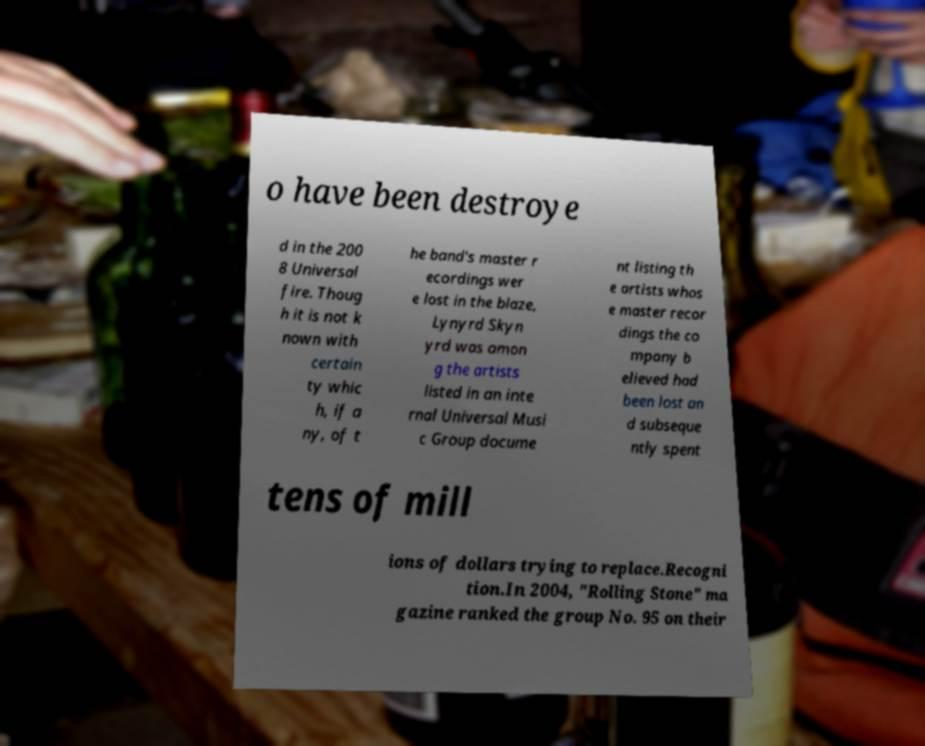Please identify and transcribe the text found in this image. o have been destroye d in the 200 8 Universal fire. Thoug h it is not k nown with certain ty whic h, if a ny, of t he band's master r ecordings wer e lost in the blaze, Lynyrd Skyn yrd was amon g the artists listed in an inte rnal Universal Musi c Group docume nt listing th e artists whos e master recor dings the co mpany b elieved had been lost an d subseque ntly spent tens of mill ions of dollars trying to replace.Recogni tion.In 2004, "Rolling Stone" ma gazine ranked the group No. 95 on their 